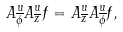<formula> <loc_0><loc_0><loc_500><loc_500>A ^ { u } _ { \overline { \phi } } A ^ { u } _ { \overline { z } } f = A ^ { u } _ { \overline { z } } A ^ { u } _ { \overline { \phi } } f ,</formula> 